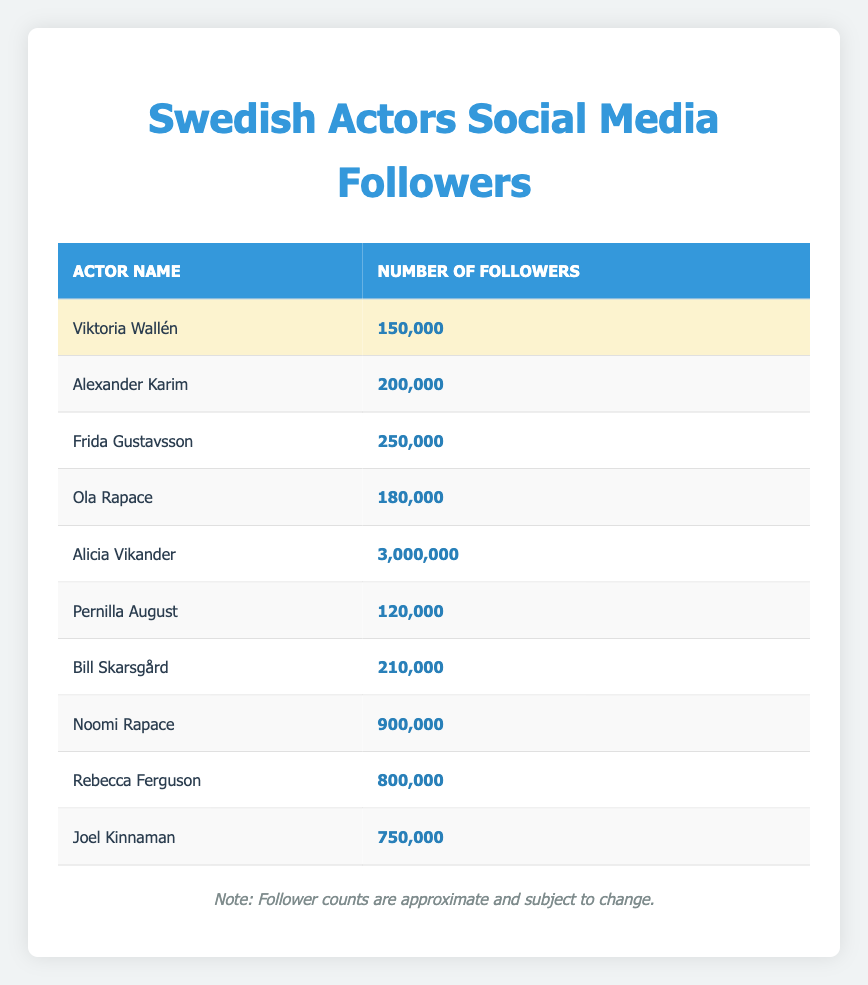What is the highest number of followers among the actors listed? The table indicates that Alicia Vikander has 3,000,000 followers, which is the highest among all actors listed.
Answer: 3,000,000 How many actors have more than 500,000 followers? To find this, I can scan the table for actors with a follower count over 500,000. These actors are: Noomi Rapace (900,000), Rebecca Ferguson (800,000), and Joel Kinnaman (750,000). Thus, there are 3 actors that have more than 500,000 followers.
Answer: 3 Who has more followers, Viktoria Wallén or Ola Rapace? Viktoria Wallén has 150,000 followers and Ola Rapace has 180,000 followers. Comparing these two values shows that Ola Rapace has more followers than Viktoria Wallén.
Answer: Ola Rapace What is the total number of followers for all the actors listed? To find the total followers, I need to add each actor's followers: 150,000 + 200,000 + 250,000 + 180,000 + 3,000,000 + 120,000 + 210,000 + 900,000 + 800,000 + 750,000 = 6,560,000. Thus, the total number of followers is 6,560,000.
Answer: 6,560,000 Is it true that Bill Skarsgård has more followers than Frida Gustavsson? Bill Skarsgård has 210,000 followers, while Frida Gustavsson has 250,000 followers. Since 210,000 is less than 250,000, this statement is false.
Answer: No 